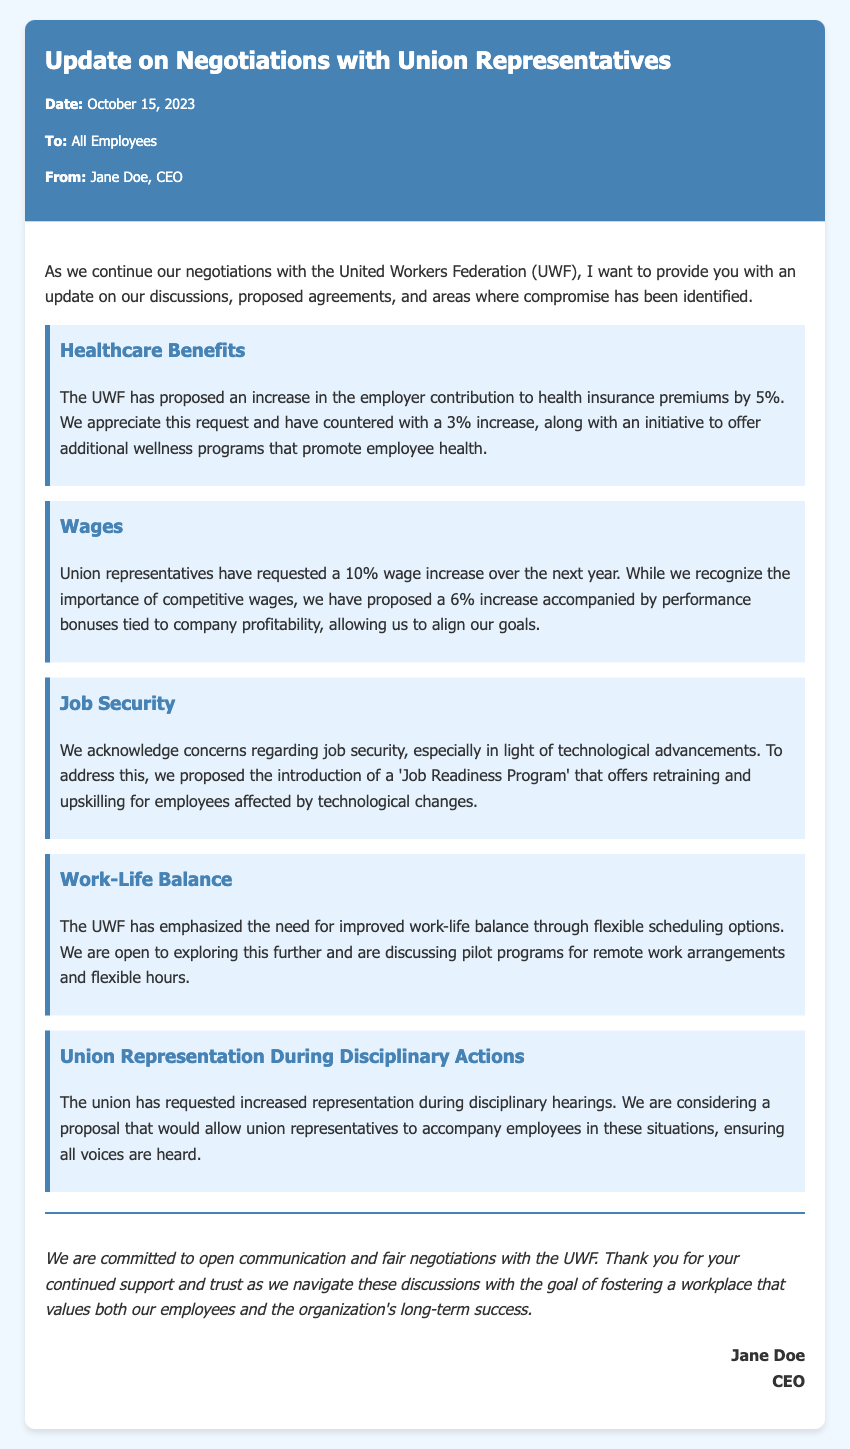What date is the memo? The date of the memo is clearly stated at the beginning of the document.
Answer: October 15, 2023 Who is the memo from? The sender of the memo is mentioned in the meta-info section.
Answer: Jane Doe, CEO What is the union's requested wage increase percentage? The document outlines the wage increase percentage requested by the union representatives.
Answer: 10% What employer contribution increase to health insurance premiums is proposed by the UWF? The memo states the proposed increase in employer contribution to health insurance premiums by the UWF.
Answer: 5% What program has been proposed to address job security? The memo specifically mentions a program aimed at addressing job security concerns.
Answer: Job Readiness Program What ratio of wage increase has been proposed by our company? The wage increase proposed by the company is highlighted separately in the memo.
Answer: 6% What is being discussed regarding work-life balance? The document outlines the areas of negotiation concerning work-life balance.
Answer: Flexible scheduling options How is the company addressing the request for union representation during disciplinary actions? The memo describes the company's proposal concerning the union's request for representation during disciplinary actions.
Answer: Allowing union representatives What is the main goal of the negotiations as stated in the conclusion? The conclusion summarizes the ultimate aim of the ongoing negotiations.
Answer: Fostering a workplace that values both our employees and the organization's long-term success 